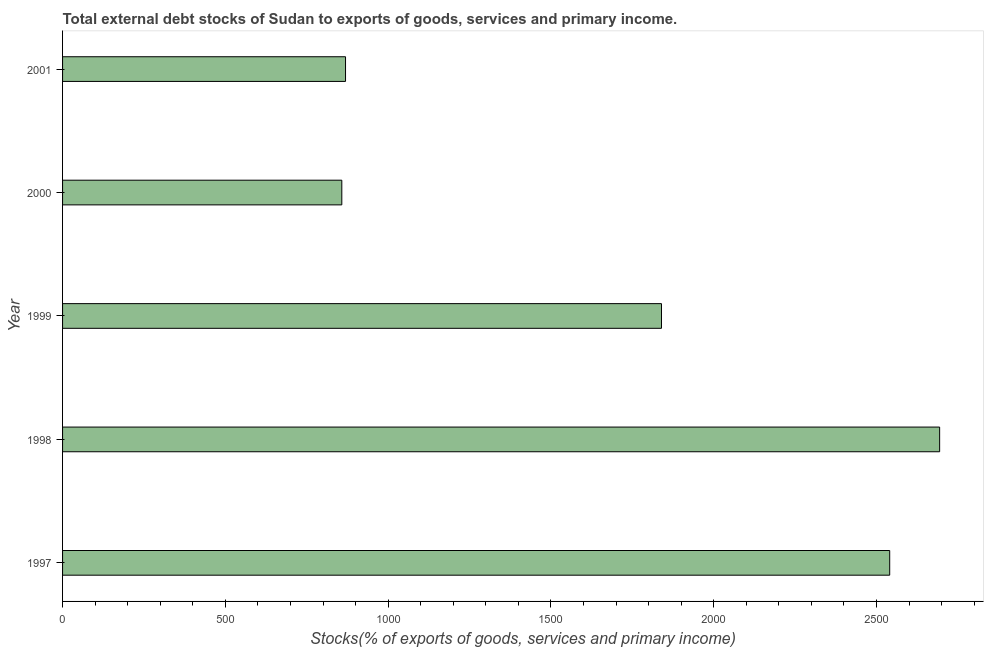Does the graph contain any zero values?
Provide a short and direct response. No. Does the graph contain grids?
Provide a short and direct response. No. What is the title of the graph?
Make the answer very short. Total external debt stocks of Sudan to exports of goods, services and primary income. What is the label or title of the X-axis?
Provide a short and direct response. Stocks(% of exports of goods, services and primary income). What is the external debt stocks in 2001?
Ensure brevity in your answer.  869.18. Across all years, what is the maximum external debt stocks?
Make the answer very short. 2694.02. Across all years, what is the minimum external debt stocks?
Your response must be concise. 857.73. In which year was the external debt stocks maximum?
Your answer should be compact. 1998. In which year was the external debt stocks minimum?
Your response must be concise. 2000. What is the sum of the external debt stocks?
Offer a very short reply. 8801.2. What is the difference between the external debt stocks in 1997 and 1999?
Provide a short and direct response. 701.01. What is the average external debt stocks per year?
Your response must be concise. 1760.24. What is the median external debt stocks?
Provide a short and direct response. 1839.63. In how many years, is the external debt stocks greater than 2100 %?
Keep it short and to the point. 2. Do a majority of the years between 1999 and 2000 (inclusive) have external debt stocks greater than 800 %?
Your answer should be very brief. Yes. Is the external debt stocks in 1998 less than that in 1999?
Give a very brief answer. No. What is the difference between the highest and the second highest external debt stocks?
Offer a very short reply. 153.38. What is the difference between the highest and the lowest external debt stocks?
Give a very brief answer. 1836.29. How many bars are there?
Provide a succinct answer. 5. Are all the bars in the graph horizontal?
Ensure brevity in your answer.  Yes. What is the difference between two consecutive major ticks on the X-axis?
Give a very brief answer. 500. What is the Stocks(% of exports of goods, services and primary income) in 1997?
Offer a terse response. 2540.64. What is the Stocks(% of exports of goods, services and primary income) in 1998?
Make the answer very short. 2694.02. What is the Stocks(% of exports of goods, services and primary income) in 1999?
Offer a terse response. 1839.63. What is the Stocks(% of exports of goods, services and primary income) in 2000?
Provide a short and direct response. 857.73. What is the Stocks(% of exports of goods, services and primary income) of 2001?
Keep it short and to the point. 869.18. What is the difference between the Stocks(% of exports of goods, services and primary income) in 1997 and 1998?
Offer a terse response. -153.38. What is the difference between the Stocks(% of exports of goods, services and primary income) in 1997 and 1999?
Offer a very short reply. 701.01. What is the difference between the Stocks(% of exports of goods, services and primary income) in 1997 and 2000?
Your answer should be very brief. 1682.91. What is the difference between the Stocks(% of exports of goods, services and primary income) in 1997 and 2001?
Ensure brevity in your answer.  1671.46. What is the difference between the Stocks(% of exports of goods, services and primary income) in 1998 and 1999?
Provide a succinct answer. 854.39. What is the difference between the Stocks(% of exports of goods, services and primary income) in 1998 and 2000?
Provide a short and direct response. 1836.29. What is the difference between the Stocks(% of exports of goods, services and primary income) in 1998 and 2001?
Your answer should be compact. 1824.84. What is the difference between the Stocks(% of exports of goods, services and primary income) in 1999 and 2000?
Ensure brevity in your answer.  981.9. What is the difference between the Stocks(% of exports of goods, services and primary income) in 1999 and 2001?
Provide a short and direct response. 970.45. What is the difference between the Stocks(% of exports of goods, services and primary income) in 2000 and 2001?
Provide a short and direct response. -11.45. What is the ratio of the Stocks(% of exports of goods, services and primary income) in 1997 to that in 1998?
Offer a very short reply. 0.94. What is the ratio of the Stocks(% of exports of goods, services and primary income) in 1997 to that in 1999?
Give a very brief answer. 1.38. What is the ratio of the Stocks(% of exports of goods, services and primary income) in 1997 to that in 2000?
Provide a short and direct response. 2.96. What is the ratio of the Stocks(% of exports of goods, services and primary income) in 1997 to that in 2001?
Make the answer very short. 2.92. What is the ratio of the Stocks(% of exports of goods, services and primary income) in 1998 to that in 1999?
Offer a terse response. 1.46. What is the ratio of the Stocks(% of exports of goods, services and primary income) in 1998 to that in 2000?
Provide a short and direct response. 3.14. What is the ratio of the Stocks(% of exports of goods, services and primary income) in 1998 to that in 2001?
Ensure brevity in your answer.  3.1. What is the ratio of the Stocks(% of exports of goods, services and primary income) in 1999 to that in 2000?
Provide a succinct answer. 2.15. What is the ratio of the Stocks(% of exports of goods, services and primary income) in 1999 to that in 2001?
Keep it short and to the point. 2.12. What is the ratio of the Stocks(% of exports of goods, services and primary income) in 2000 to that in 2001?
Your answer should be compact. 0.99. 